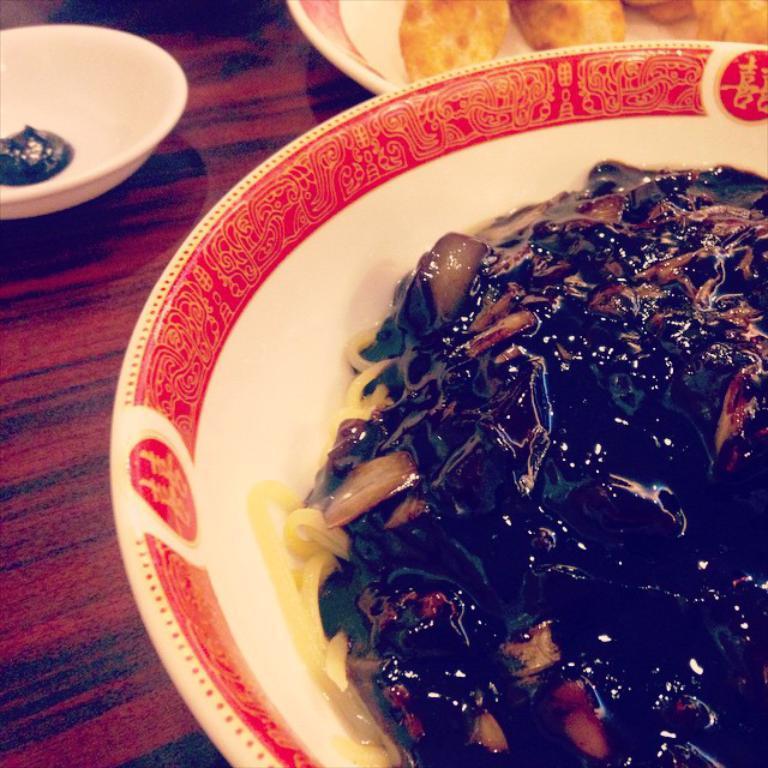Please provide a concise description of this image. In this image there is a table, on that table there are two plates, in that plates there is food item and there is a bowl in that bowl there is food item. 